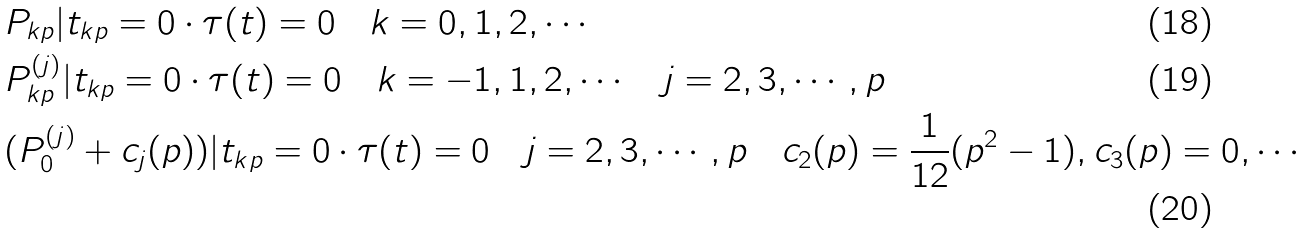<formula> <loc_0><loc_0><loc_500><loc_500>& P _ { k p } | t _ { k p } = 0 \cdot \tau ( t ) = 0 \quad k = 0 , 1 , 2 , \cdots \\ & P ^ { ( j ) } _ { k p } | t _ { k p } = 0 \cdot \tau ( t ) = 0 \quad k = - 1 , 1 , 2 , \cdots \quad j = 2 , 3 , \cdots , p \\ & ( P ^ { ( j ) } _ { 0 } + c _ { j } ( p ) ) | t _ { k p } = 0 \cdot \tau ( t ) = 0 \quad j = 2 , 3 , \cdots , p \quad c _ { 2 } ( p ) = \frac { 1 } { 1 2 } ( p ^ { 2 } - 1 ) , c _ { 3 } ( p ) = 0 , \cdots</formula> 